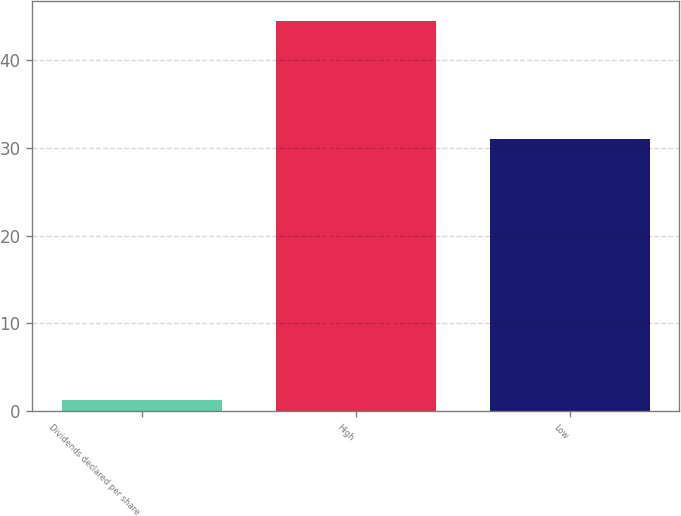Convert chart. <chart><loc_0><loc_0><loc_500><loc_500><bar_chart><fcel>Dividends declared per share<fcel>High<fcel>Low<nl><fcel>1.31<fcel>44.46<fcel>30.96<nl></chart> 